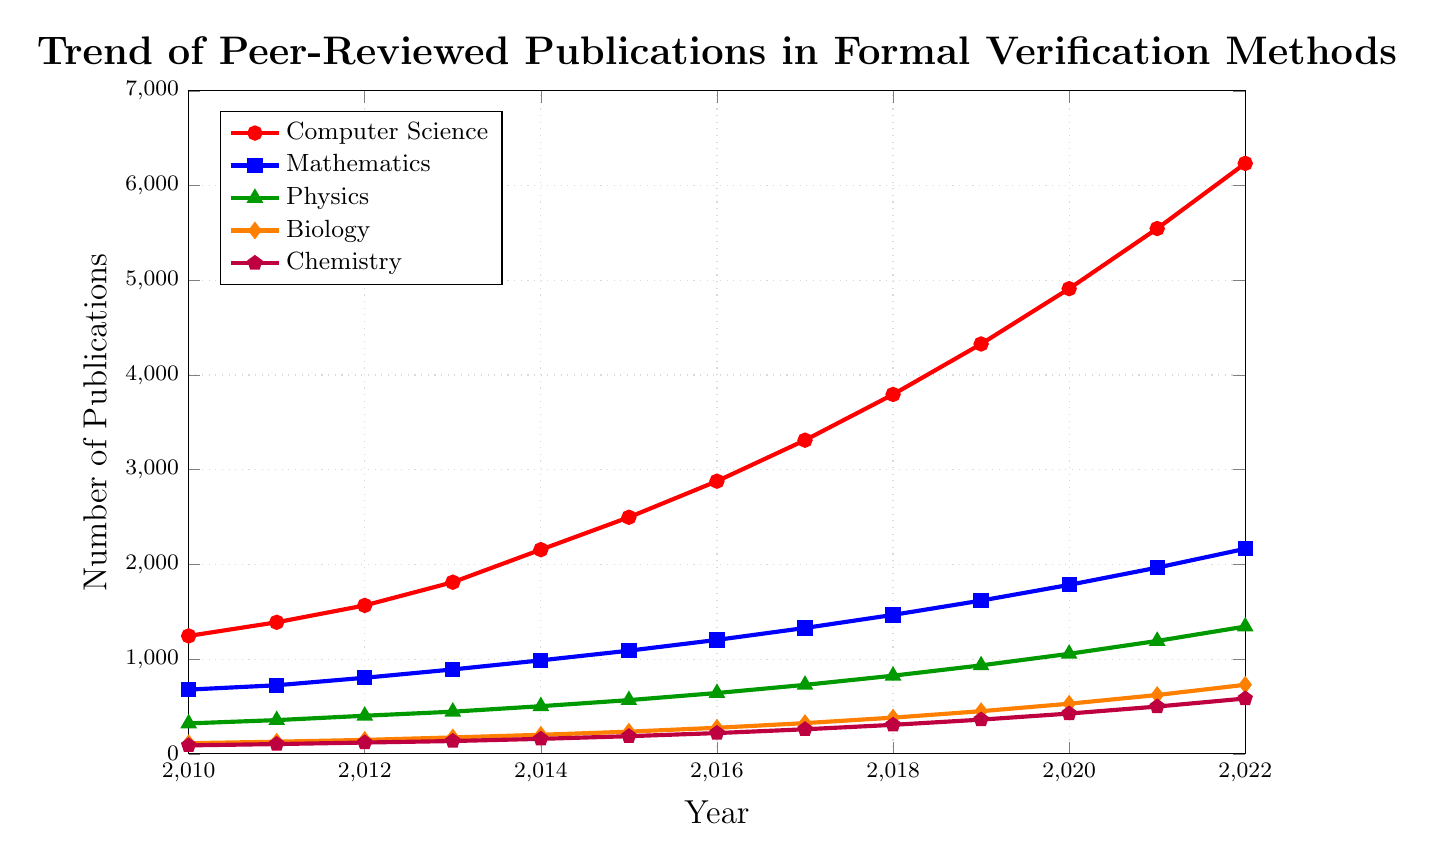Which discipline had the highest number of publications in 2022? Identify the lines for each discipline, trace them to 2022, and compare their endpoints. Computer Science has the highest endpoint.
Answer: Computer Science Between 2014 and 2015, which discipline had the smallest increase in publications? Compare the differences in publication counts from 2014 to 2015 for each discipline. Computer Science (2156 to 2498), Mathematics (987 to 1089), Physics (503 to 567), Biology (201 to 234), Chemistry (158 to 186). Chemistry has the smallest increase (28).
Answer: Chemistry What is the overall trend in the number of publications for Biology from 2010 to 2022? Observe the line representing Biology from 2010 to 2022. Notice the general upward slope.
Answer: Increasing Which two disciplines had the closest number of publications in 2020? Compare the publication numbers for each discipline in 2020: Computer Science (4912), Mathematics (1784), Physics (1056), Biology (529), Chemistry (425). Biology and Chemistry are closest (529 and 425).
Answer: Biology and Chemistry How many more publications were there in Mathematics than in Physics in 2016? Subtract the number of Physics publications in 2016 (642) from Mathematics publications in 2016 (1203). 1203 - 642 = 561
Answer: 561 Which discipline showed the most consistent year-over-year increase? Analyze the lines for smoothness and overall consistent rise. Mathematics shows the most consistent increase compared to the other disciplines, as its line has the least deviation in slope.
Answer: Mathematics Between 2010 and 2013, what was the increase in publications for Physics? Subtract the number of Physics publications in 2010 (321) from the number in 2013 (445). 445 - 321 = 124
Answer: 124 In which year did Computer Science publications first exceed 3000? Trace the Computer Science line to find the year where it first crosses 3000. It crosses between 2016 and 2017. In 2017, the count is 3312.
Answer: 2017 What is the average number of publications for Chemistry across the given years? Sum the total number of Chemistry publications from 2010 to 2022 and divide by the number of years (13). (89+103+119+135+158+186+219+259+306+361+425+499+584)/13 = 2707/13 ≈ 208.23
Answer: 208.23 